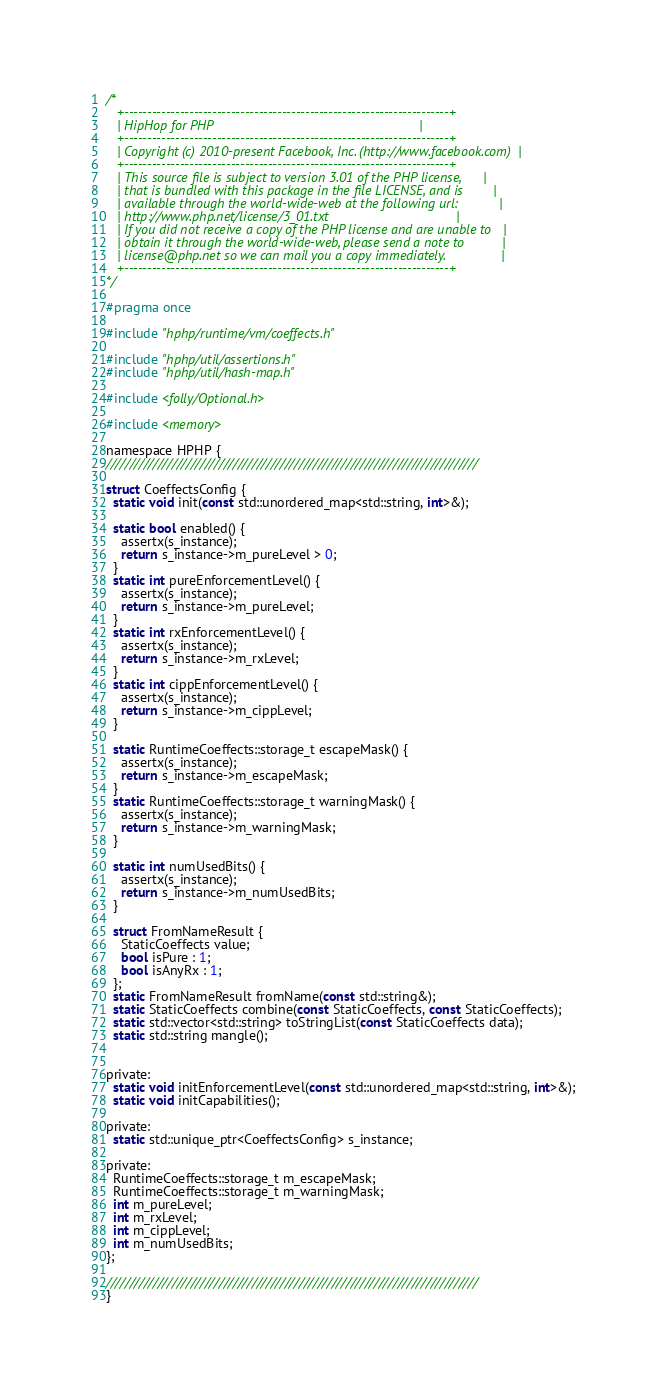<code> <loc_0><loc_0><loc_500><loc_500><_C_>/*
   +----------------------------------------------------------------------+
   | HipHop for PHP                                                       |
   +----------------------------------------------------------------------+
   | Copyright (c) 2010-present Facebook, Inc. (http://www.facebook.com)  |
   +----------------------------------------------------------------------+
   | This source file is subject to version 3.01 of the PHP license,      |
   | that is bundled with this package in the file LICENSE, and is        |
   | available through the world-wide-web at the following url:           |
   | http://www.php.net/license/3_01.txt                                  |
   | If you did not receive a copy of the PHP license and are unable to   |
   | obtain it through the world-wide-web, please send a note to          |
   | license@php.net so we can mail you a copy immediately.               |
   +----------------------------------------------------------------------+
*/

#pragma once

#include "hphp/runtime/vm/coeffects.h"

#include "hphp/util/assertions.h"
#include "hphp/util/hash-map.h"

#include <folly/Optional.h>

#include <memory>

namespace HPHP {
///////////////////////////////////////////////////////////////////////////////

struct CoeffectsConfig {
  static void init(const std::unordered_map<std::string, int>&);

  static bool enabled() {
    assertx(s_instance);
    return s_instance->m_pureLevel > 0;
  }
  static int pureEnforcementLevel() {
    assertx(s_instance);
    return s_instance->m_pureLevel;
  }
  static int rxEnforcementLevel() {
    assertx(s_instance);
    return s_instance->m_rxLevel;
  }
  static int cippEnforcementLevel() {
    assertx(s_instance);
    return s_instance->m_cippLevel;
  }

  static RuntimeCoeffects::storage_t escapeMask() {
    assertx(s_instance);
    return s_instance->m_escapeMask;
  }
  static RuntimeCoeffects::storage_t warningMask() {
    assertx(s_instance);
    return s_instance->m_warningMask;
  }

  static int numUsedBits() {
    assertx(s_instance);
    return s_instance->m_numUsedBits;
  }

  struct FromNameResult {
    StaticCoeffects value;
    bool isPure : 1;
    bool isAnyRx : 1;
  };
  static FromNameResult fromName(const std::string&);
  static StaticCoeffects combine(const StaticCoeffects, const StaticCoeffects);
  static std::vector<std::string> toStringList(const StaticCoeffects data);
  static std::string mangle();


private:
  static void initEnforcementLevel(const std::unordered_map<std::string, int>&);
  static void initCapabilities();

private:
  static std::unique_ptr<CoeffectsConfig> s_instance;

private:
  RuntimeCoeffects::storage_t m_escapeMask;
  RuntimeCoeffects::storage_t m_warningMask;
  int m_pureLevel;
  int m_rxLevel;
  int m_cippLevel;
  int m_numUsedBits;
};

///////////////////////////////////////////////////////////////////////////////
}

</code> 